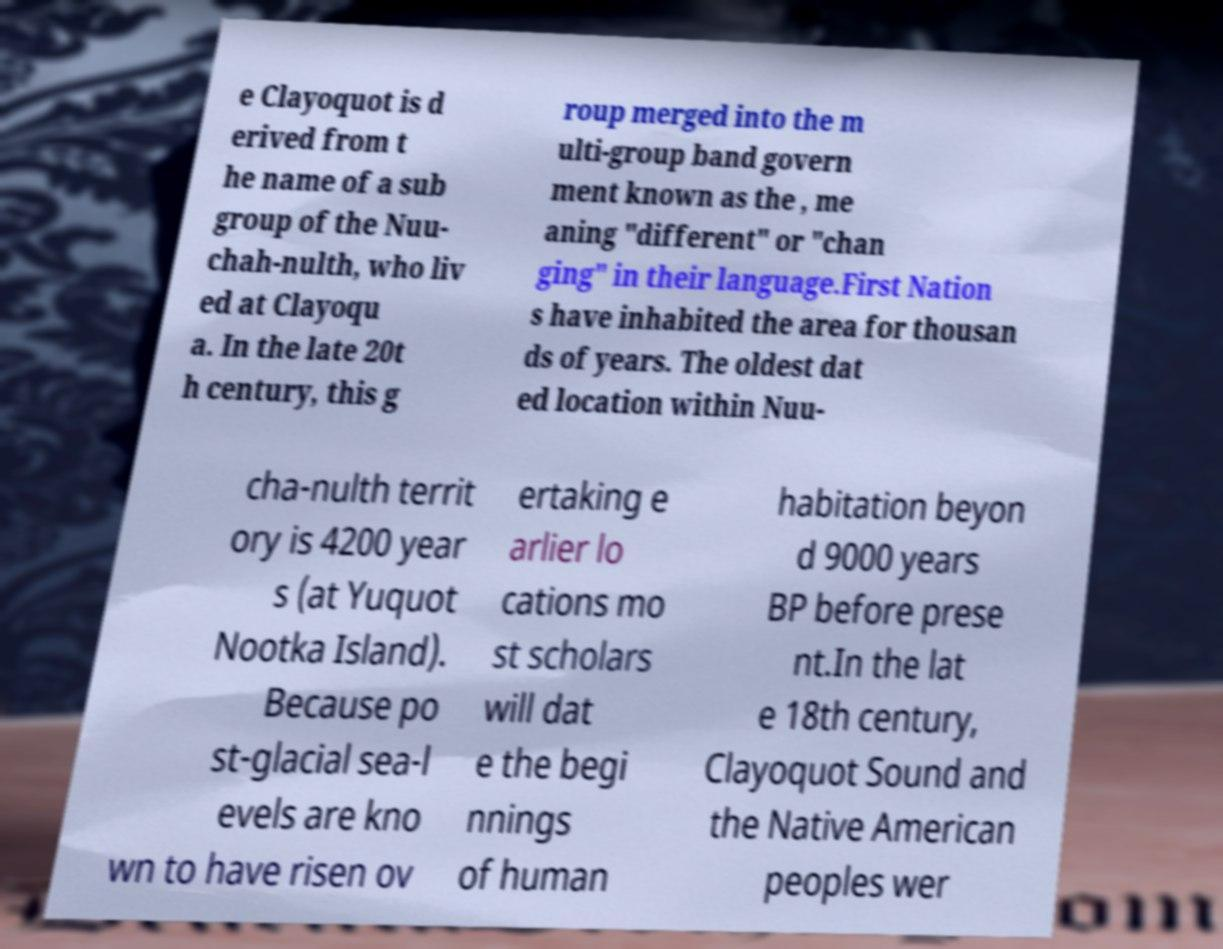Can you accurately transcribe the text from the provided image for me? e Clayoquot is d erived from t he name of a sub group of the Nuu- chah-nulth, who liv ed at Clayoqu a. In the late 20t h century, this g roup merged into the m ulti-group band govern ment known as the , me aning "different" or "chan ging" in their language.First Nation s have inhabited the area for thousan ds of years. The oldest dat ed location within Nuu- cha-nulth territ ory is 4200 year s (at Yuquot Nootka Island). Because po st-glacial sea-l evels are kno wn to have risen ov ertaking e arlier lo cations mo st scholars will dat e the begi nnings of human habitation beyon d 9000 years BP before prese nt.In the lat e 18th century, Clayoquot Sound and the Native American peoples wer 